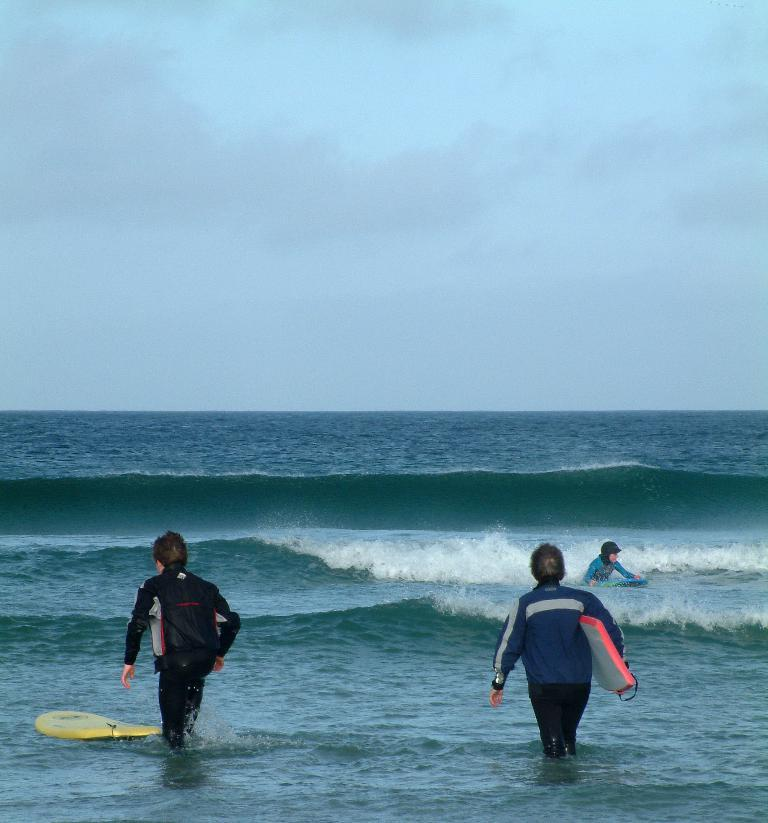What type of water body is shown in the image? The image depicts a freshwater river. What is the condition of the sky in the image? The sky is cloudy in the image. What activity is the person in the image engaged in? The person is surfing a board. What object is the person holding in the image? The person is holding a surfboard. How is the person positioned while surfing? The person is standing while surfing. What type of food is the woman eating in the image? There is no woman or food present in the image; it features a person surfing a board in a freshwater river. 